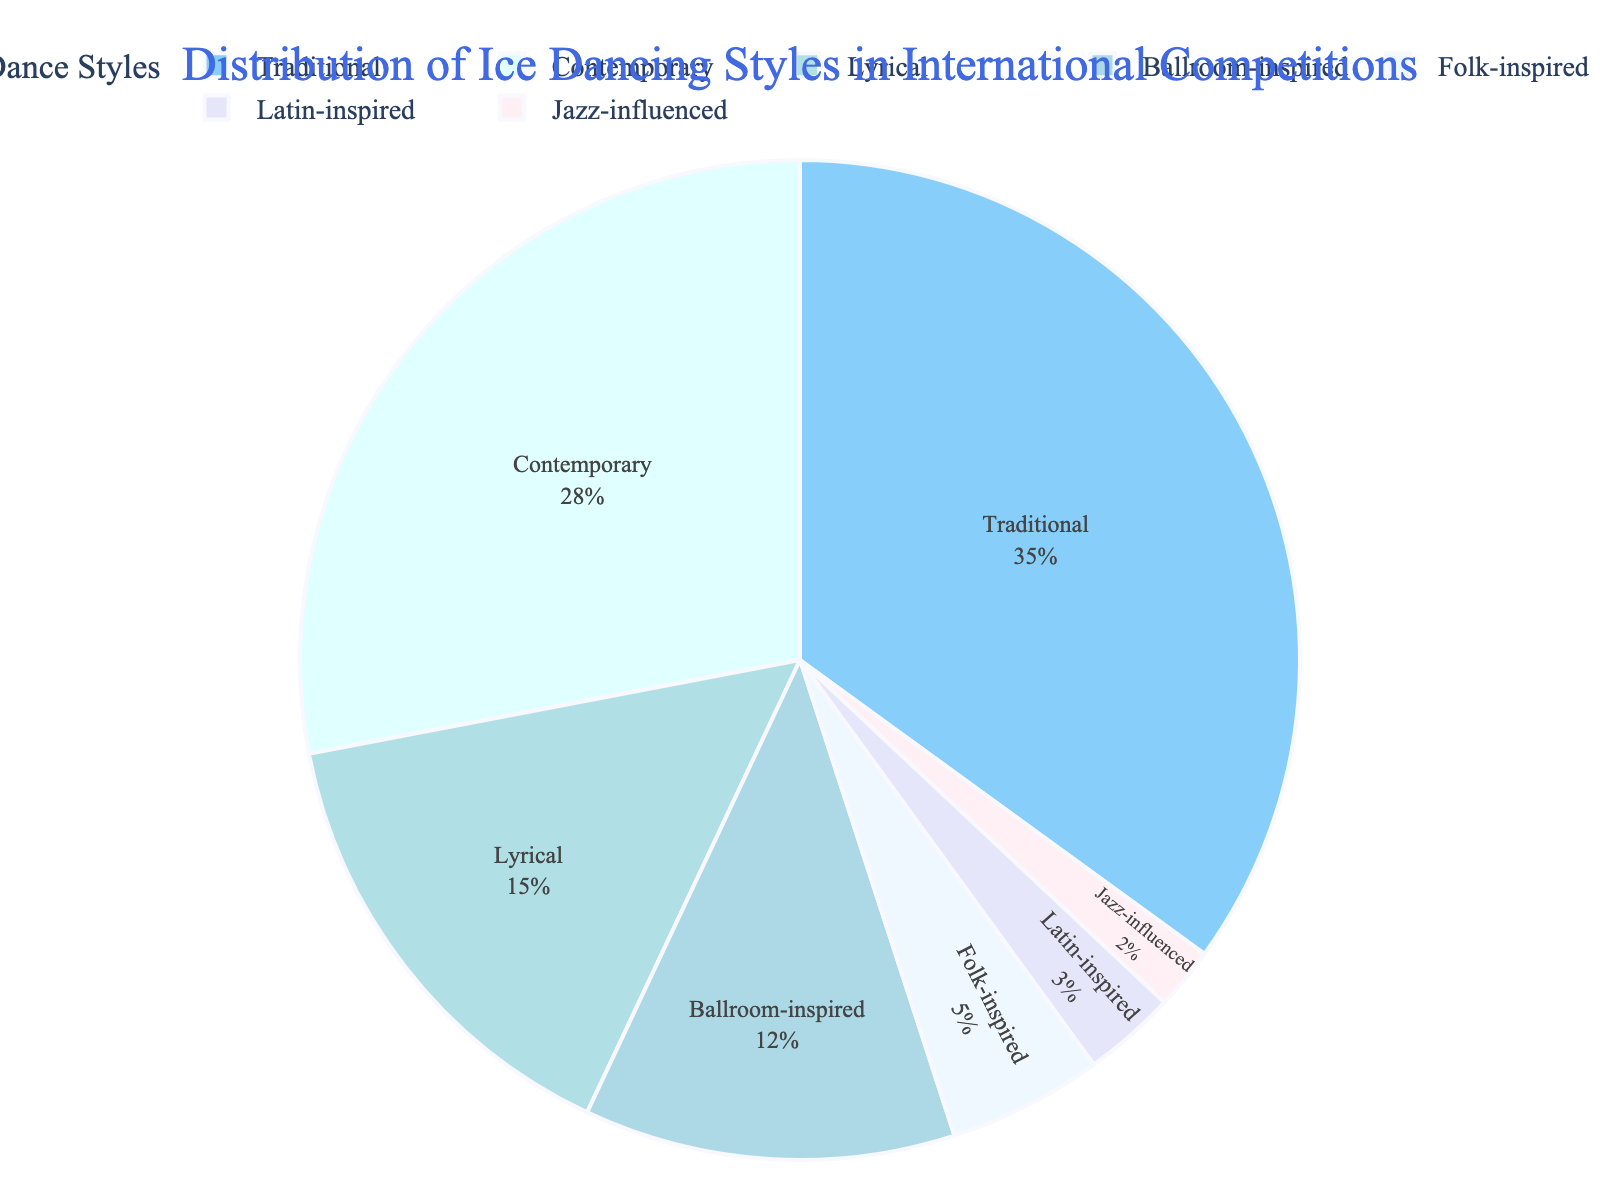Which ice dance style is the most popular in international competitions? The pie chart shows the distribution percentages of different ice dance styles. The largest segment of the pie chart represents "Traditional" with 35%.
Answer: Traditional Which two ice dance styles combined represent more than half of the whole distribution? By looking at the percentages in the pie chart, we see that "Traditional" (35%) and "Contemporary" (28%) are the two largest segments. Adding their percentages: 35% + 28% = 63%, which is more than half the distribution.
Answer: Traditional and Contemporary What is the percentage difference between "Ballroom-inspired" and "Folk-inspired" styles? The pie chart shows that "Ballroom-inspired" has 12% and "Folk-inspired" has 5%. The difference is calculated as 12% - 5% = 7%.
Answer: 7% If "Lyrical" and "Jazz-influenced" styles were combined, would their new percentage be greater than "Contemporary"? The percentages for "Lyrical" and "Jazz-influenced" are 15% and 2% respectively. Adding these gives 15% + 2% = 17%. Comparing this to "Contemporary" which is 28%, we see that 17% is not greater than 28%.
Answer: No Arrange the ice dance styles in descending order of their popularity. By looking at the pie chart, the percentages are as follows: Traditional (35%), Contemporary (28%), Lyrical (15%), Ballroom-inspired (12%), Folk-inspired (5%), Latin-inspired (3%), Jazz-influenced (2%).
Answer: Traditional, Contemporary, Lyrical, Ballroom-inspired, Folk-inspired, Latin-inspired, Jazz-influenced What is the total percentage of all styles that have less than 10% representation? The pie chart shows the following percentages for styles with less than 10%: Folk-inspired (5%), Latin-inspired (3%), and Jazz-influenced (2%). Adding these gives 5% + 3% + 2% = 10%.
Answer: 10% Which style has the smallest representation in international competitions? When looking at the pie chart, the smallest segment belongs to "Jazz-influenced" which is 2%.
Answer: Jazz-influenced How does the share of "Latin-inspired" compare to "Ballroom-inspired"? The pie chart indicates that "Latin-inspired" is 3% and "Ballroom-inspired" is 12%. Ballroom-inspired has a greater percentage.
Answer: Ballroom-inspired is greater Considering the three least popular styles, what percentage of the whole do they cover together? From the pie chart, the three least popular styles are Folk-inspired (5%), Latin-inspired (3%), and Jazz-influenced (2%). Adding these gives 5% + 3% + 2% = 10%.
Answer: 10% What proportion of the pie chart is occupied by non-traditional styles? The percentage of "Traditional" is 35%, meaning non-traditional styles account for 100% - 35% = 65% of the pie chart.
Answer: 65% 